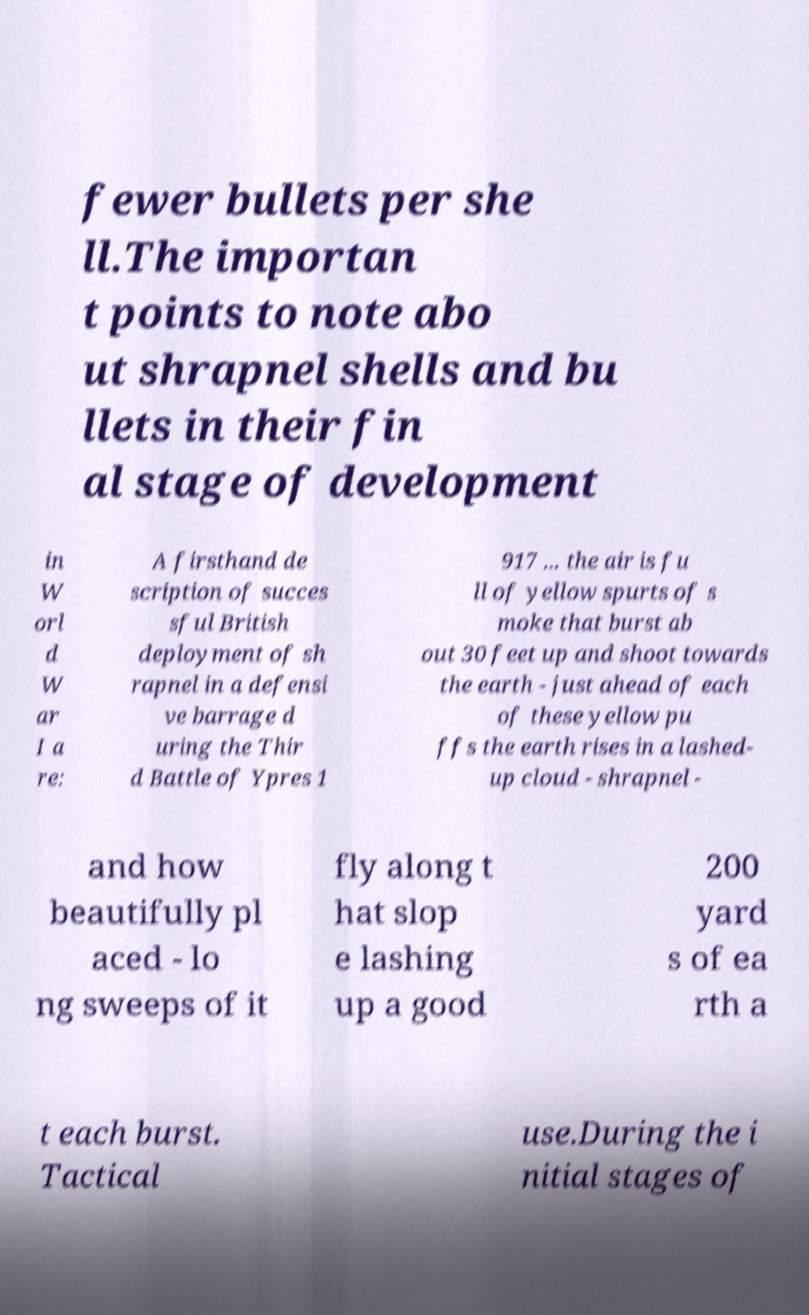For documentation purposes, I need the text within this image transcribed. Could you provide that? fewer bullets per she ll.The importan t points to note abo ut shrapnel shells and bu llets in their fin al stage of development in W orl d W ar I a re: A firsthand de scription of succes sful British deployment of sh rapnel in a defensi ve barrage d uring the Thir d Battle of Ypres 1 917 ... the air is fu ll of yellow spurts of s moke that burst ab out 30 feet up and shoot towards the earth - just ahead of each of these yellow pu ffs the earth rises in a lashed- up cloud - shrapnel - and how beautifully pl aced - lo ng sweeps of it fly along t hat slop e lashing up a good 200 yard s of ea rth a t each burst. Tactical use.During the i nitial stages of 